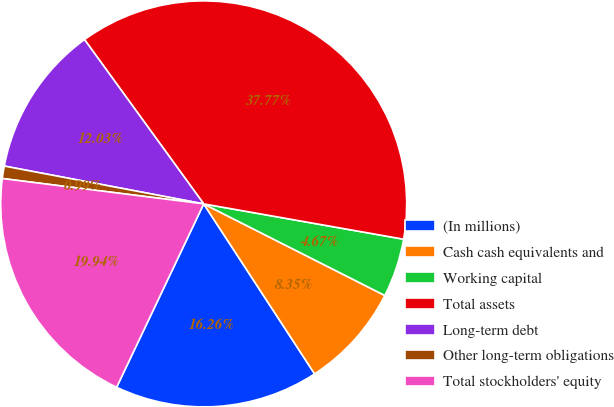Convert chart to OTSL. <chart><loc_0><loc_0><loc_500><loc_500><pie_chart><fcel>(In millions)<fcel>Cash cash equivalents and<fcel>Working capital<fcel>Total assets<fcel>Long-term debt<fcel>Other long-term obligations<fcel>Total stockholders' equity<nl><fcel>16.26%<fcel>8.35%<fcel>4.67%<fcel>37.78%<fcel>12.03%<fcel>0.99%<fcel>19.94%<nl></chart> 